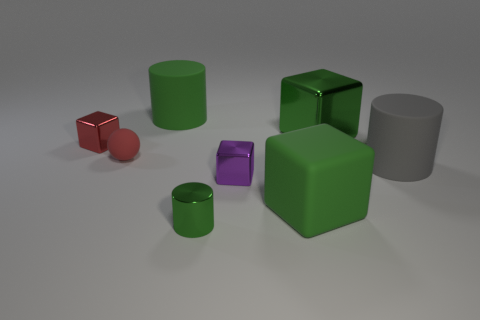Subtract all shiny cylinders. How many cylinders are left? 2 Subtract 1 cylinders. How many cylinders are left? 2 Add 2 yellow metal spheres. How many objects exist? 10 Subtract all purple cubes. How many cubes are left? 3 Subtract 2 green blocks. How many objects are left? 6 Subtract all balls. How many objects are left? 7 Subtract all purple cylinders. Subtract all green cubes. How many cylinders are left? 3 Subtract all yellow cylinders. How many purple balls are left? 0 Subtract all matte balls. Subtract all metal cubes. How many objects are left? 4 Add 6 gray things. How many gray things are left? 7 